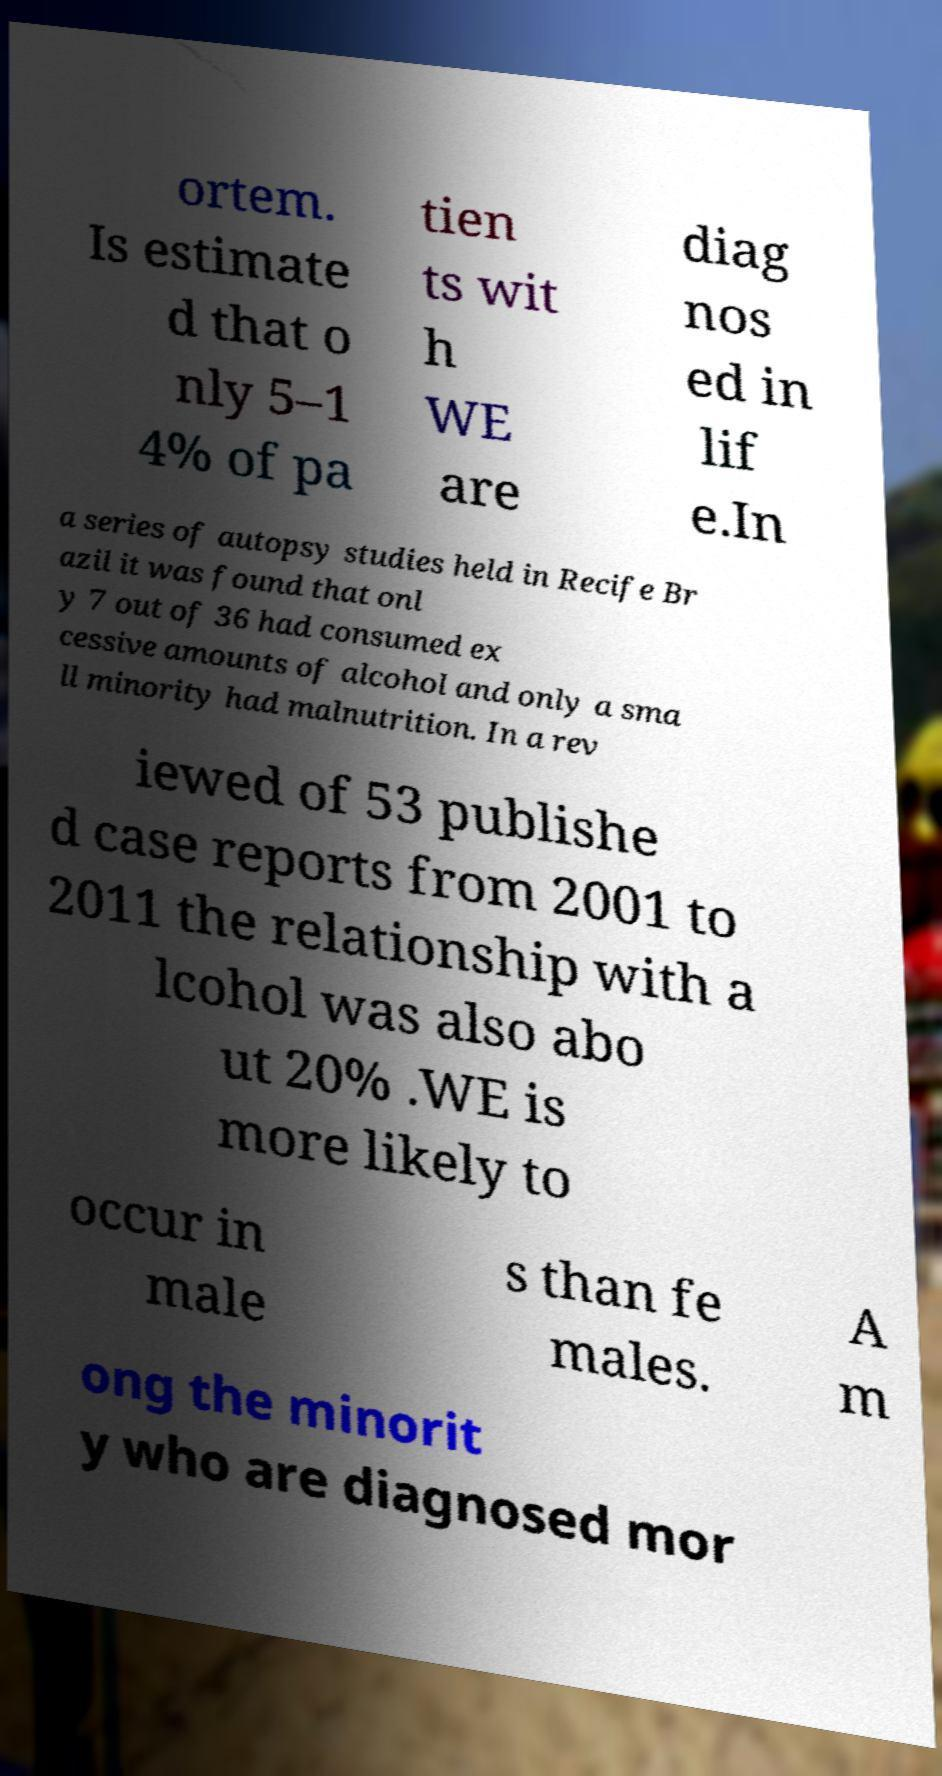Could you assist in decoding the text presented in this image and type it out clearly? ortem. Is estimate d that o nly 5–1 4% of pa tien ts wit h WE are diag nos ed in lif e.In a series of autopsy studies held in Recife Br azil it was found that onl y 7 out of 36 had consumed ex cessive amounts of alcohol and only a sma ll minority had malnutrition. In a rev iewed of 53 publishe d case reports from 2001 to 2011 the relationship with a lcohol was also abo ut 20% .WE is more likely to occur in male s than fe males. A m ong the minorit y who are diagnosed mor 